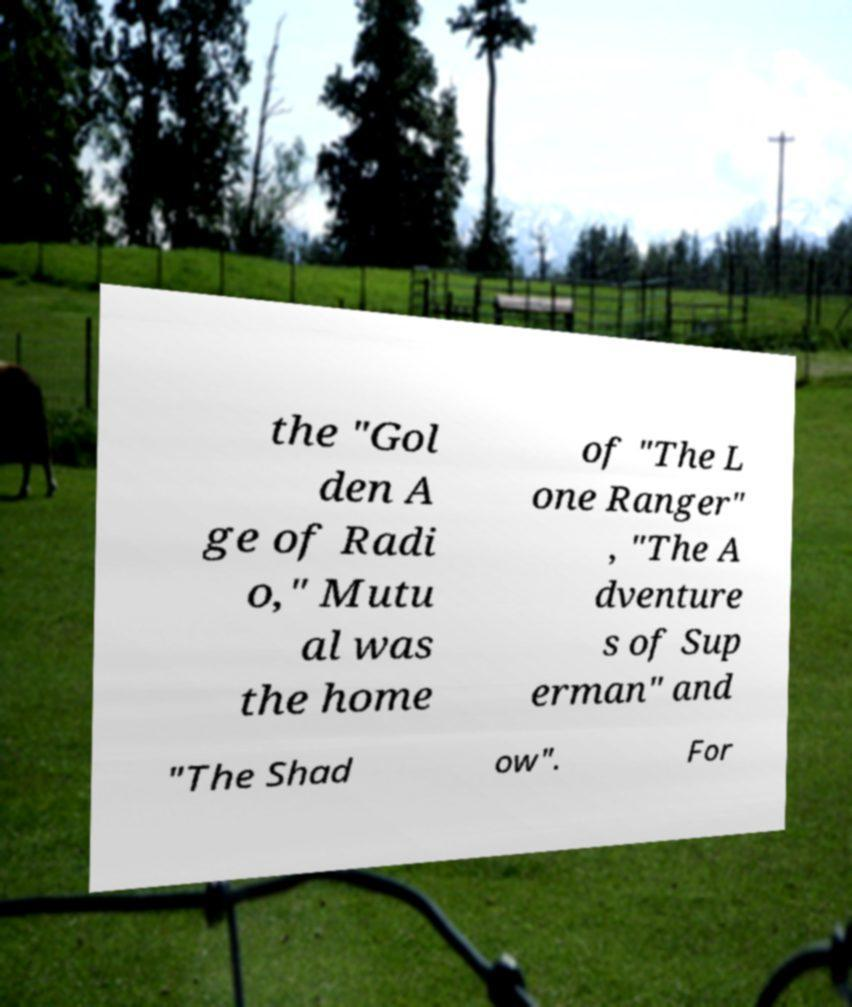Please identify and transcribe the text found in this image. the "Gol den A ge of Radi o," Mutu al was the home of "The L one Ranger" , "The A dventure s of Sup erman" and "The Shad ow". For 